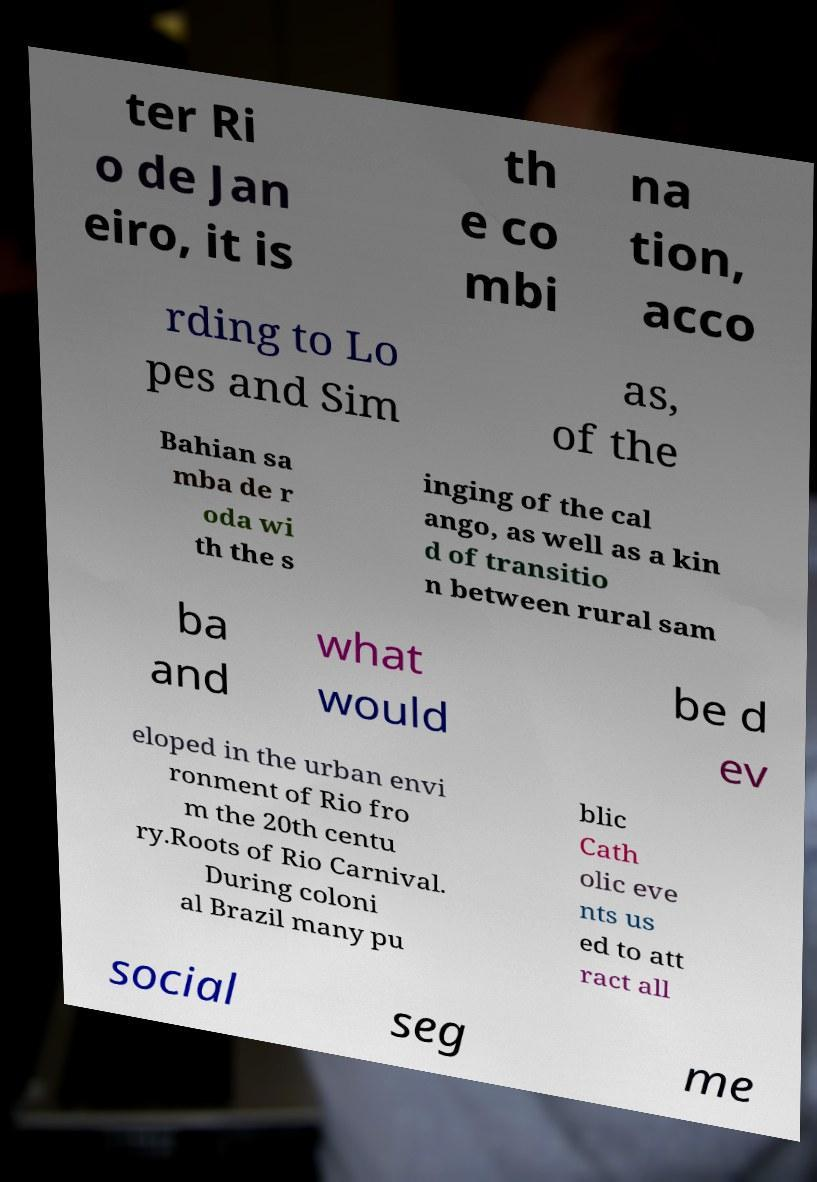Could you extract and type out the text from this image? ter Ri o de Jan eiro, it is th e co mbi na tion, acco rding to Lo pes and Sim as, of the Bahian sa mba de r oda wi th the s inging of the cal ango, as well as a kin d of transitio n between rural sam ba and what would be d ev eloped in the urban envi ronment of Rio fro m the 20th centu ry.Roots of Rio Carnival. During coloni al Brazil many pu blic Cath olic eve nts us ed to att ract all social seg me 